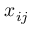Convert formula to latex. <formula><loc_0><loc_0><loc_500><loc_500>x _ { i j }</formula> 